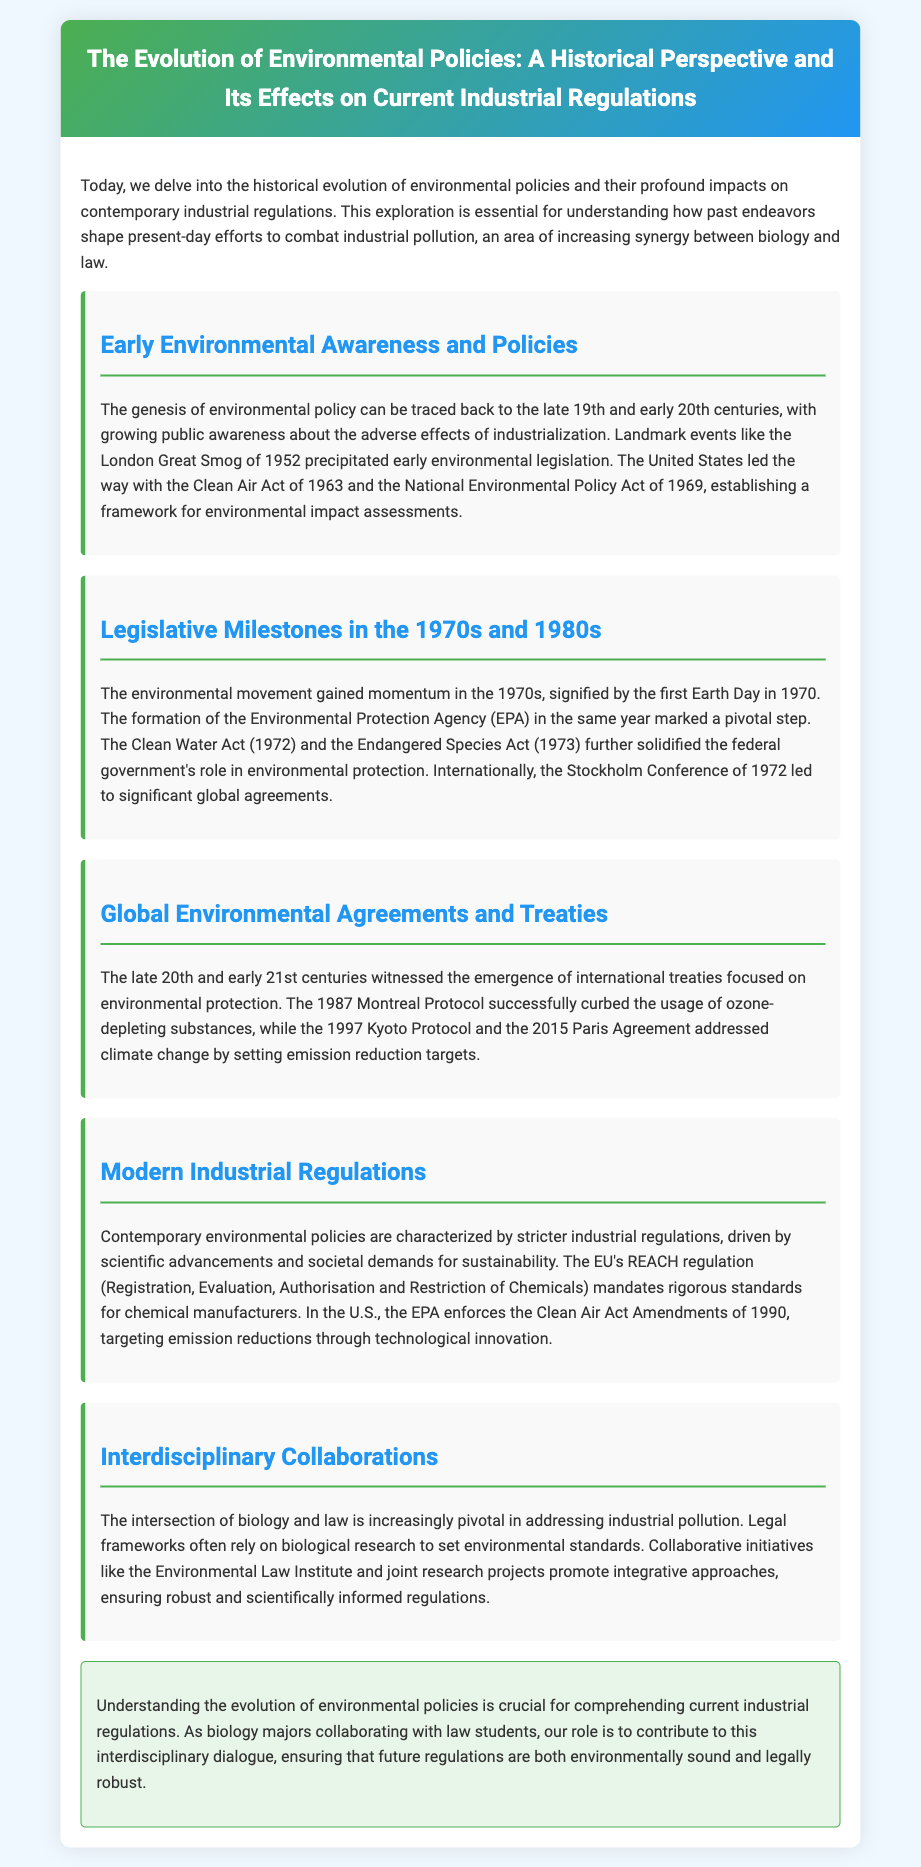What event precipitated early environmental legislation? The London Great Smog of 1952 was a landmark event that raised public awareness about industrial pollution, leading to early environmental legislation.
Answer: London Great Smog of 1952 When was the Environmental Protection Agency formed? The Environmental Protection Agency (EPA) was formed in 1970, marking a pivotal step in the U.S. environmental movement.
Answer: 1970 What act was established in the U.S. in 1963? The Clean Air Act was established in the United States in 1963 as a significant piece of environmental legislation.
Answer: Clean Air Act Which international agreement successfully curbed ozone-depleting substances? The Montreal Protocol, established in 1987, successfully addressed the issue of ozone-depleting substances.
Answer: Montreal Protocol What does the EU's REACH regulation stand for? REACH stands for Registration, Evaluation, Authorisation and Restriction of Chemicals, representing the EU's chemical safety framework.
Answer: Registration, Evaluation, Authorisation and Restriction of Chemicals How is the intersection of biology and law described in the document? The intersection is described as increasingly pivotal in addressing industrial pollution, relying on biological research for setting environmental standards.
Answer: Increasingly pivotal What year does the Clean Water Act date back to? The Clean Water Act was established in 1972 as a major federal law in the U.S. for protecting water resources.
Answer: 1972 Which significant global conference took place in 1972? The Stockholm Conference, held in 1972, was a significant global event regarding environmental issues.
Answer: Stockholm Conference What approach do collaborations like the Environmental Law Institute promote? These collaborations promote integrative approaches to ensure robust and scientifically informed regulations.
Answer: Integrative approaches 